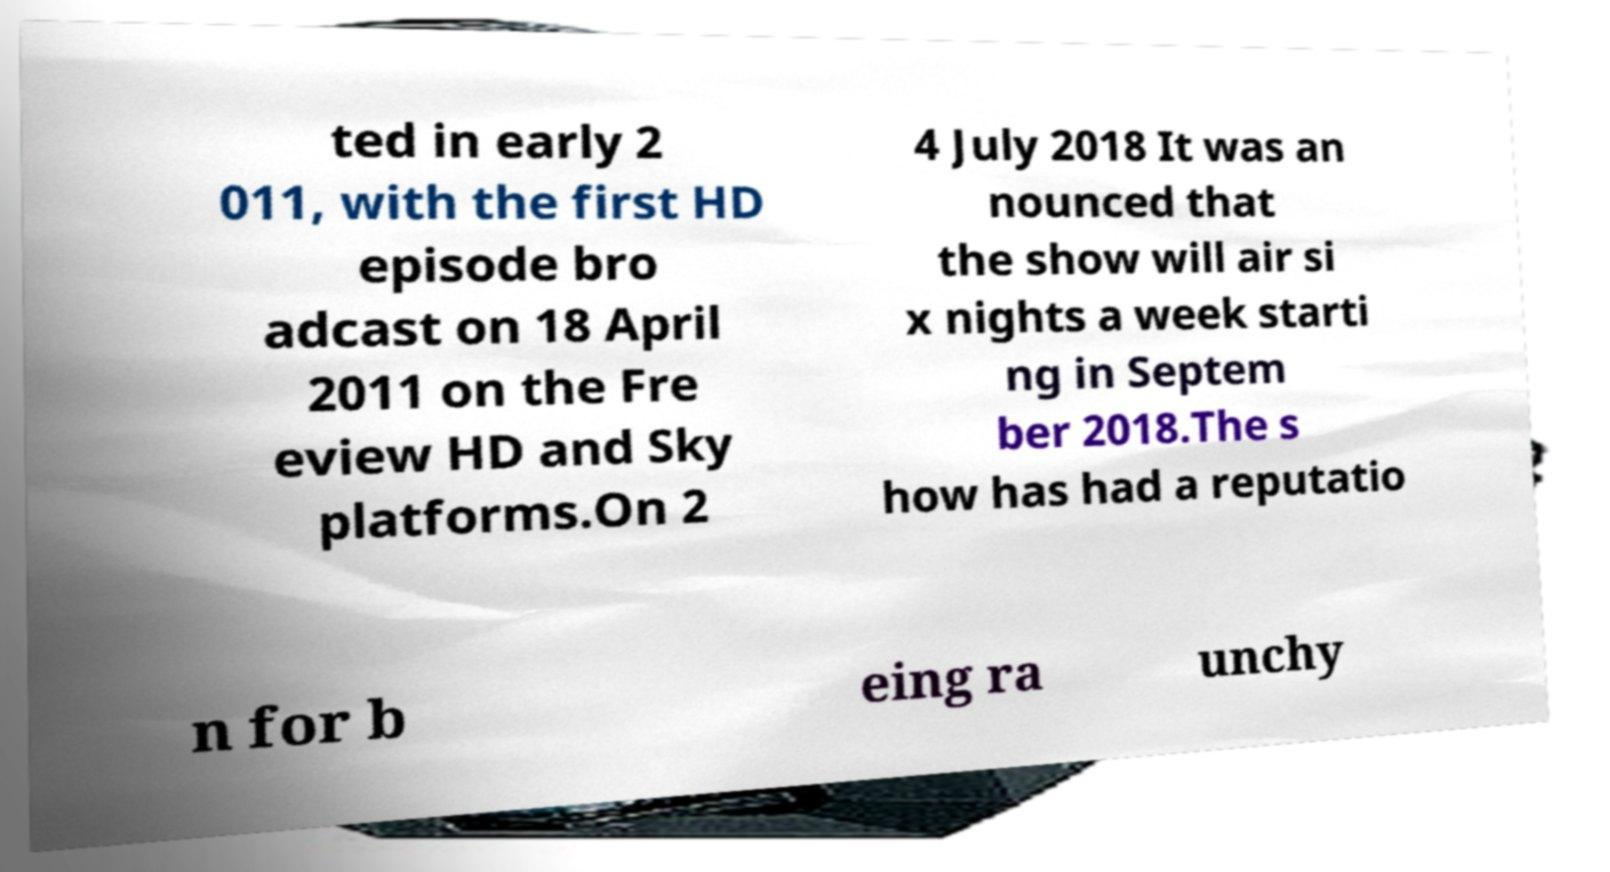There's text embedded in this image that I need extracted. Can you transcribe it verbatim? ted in early 2 011, with the first HD episode bro adcast on 18 April 2011 on the Fre eview HD and Sky platforms.On 2 4 July 2018 It was an nounced that the show will air si x nights a week starti ng in Septem ber 2018.The s how has had a reputatio n for b eing ra unchy 